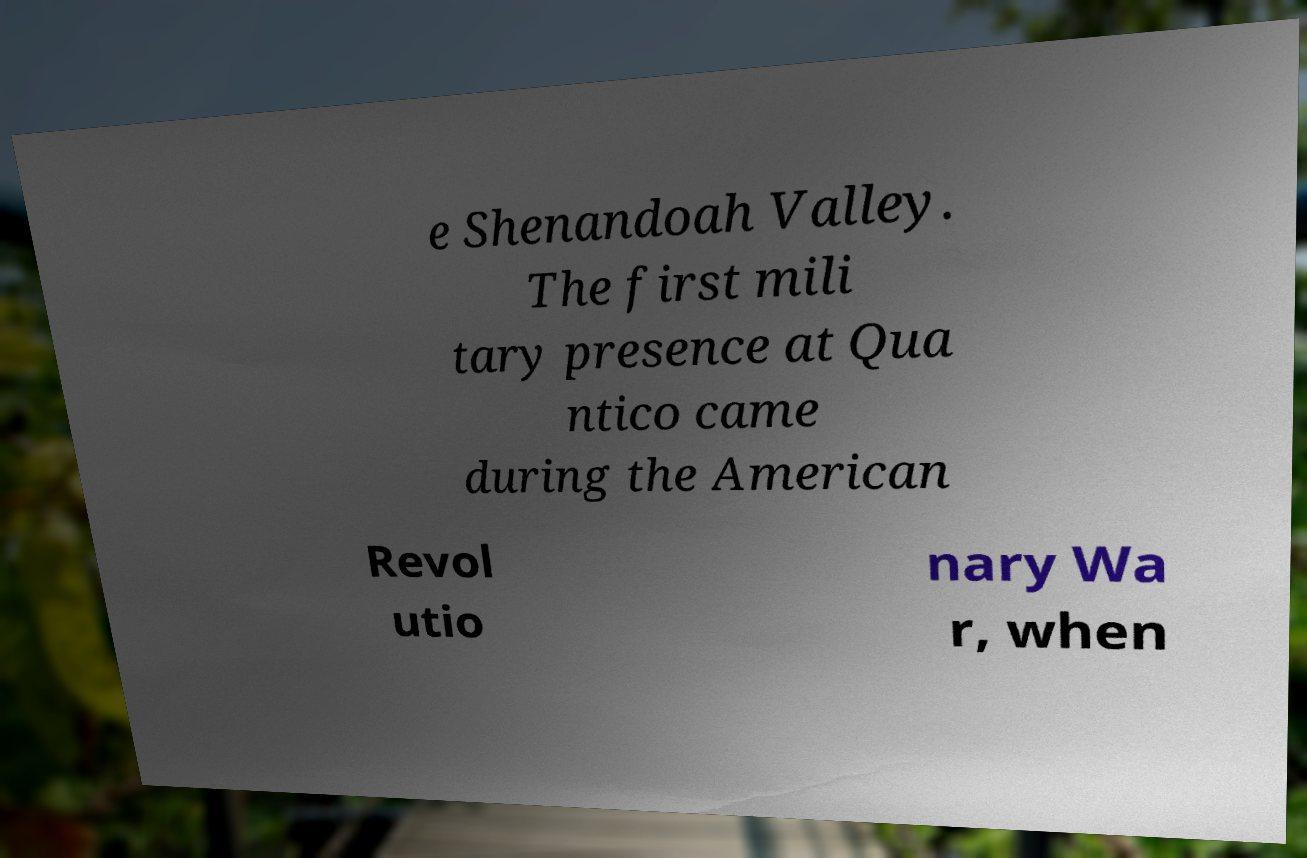Could you assist in decoding the text presented in this image and type it out clearly? e Shenandoah Valley. The first mili tary presence at Qua ntico came during the American Revol utio nary Wa r, when 